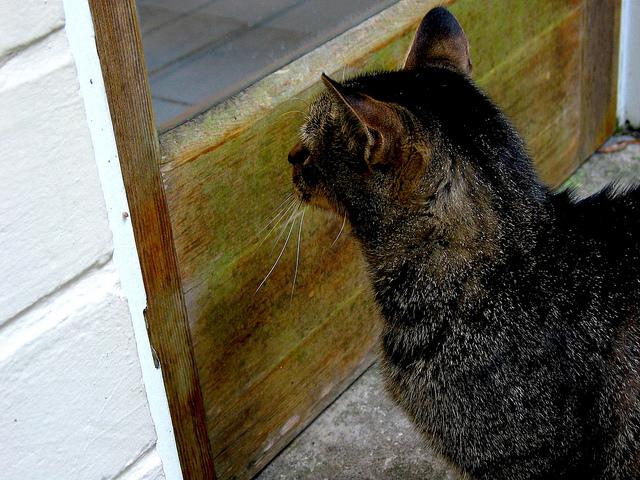What is the item next to the cat?
Quick response, please. Door. What color is the cat?
Write a very short answer. Black. What is the cat looking at?
Quick response, please. Door. Is this a backdoor?
Quick response, please. Yes. 